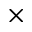Convert formula to latex. <formula><loc_0><loc_0><loc_500><loc_500>\times</formula> 